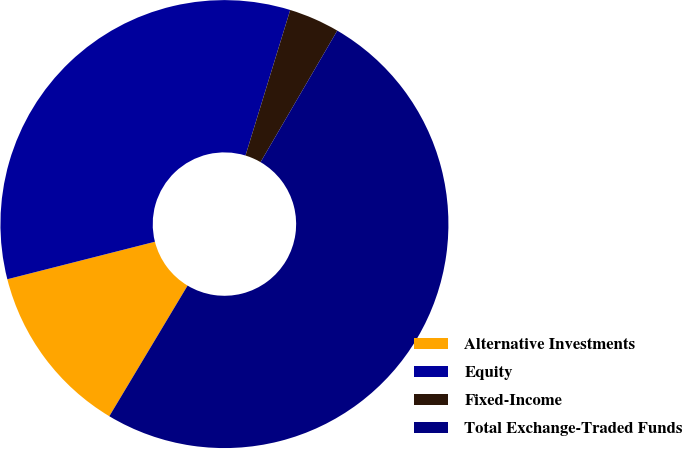Convert chart. <chart><loc_0><loc_0><loc_500><loc_500><pie_chart><fcel>Alternative Investments<fcel>Equity<fcel>Fixed-Income<fcel>Total Exchange-Traded Funds<nl><fcel>12.45%<fcel>33.7%<fcel>3.66%<fcel>50.18%<nl></chart> 